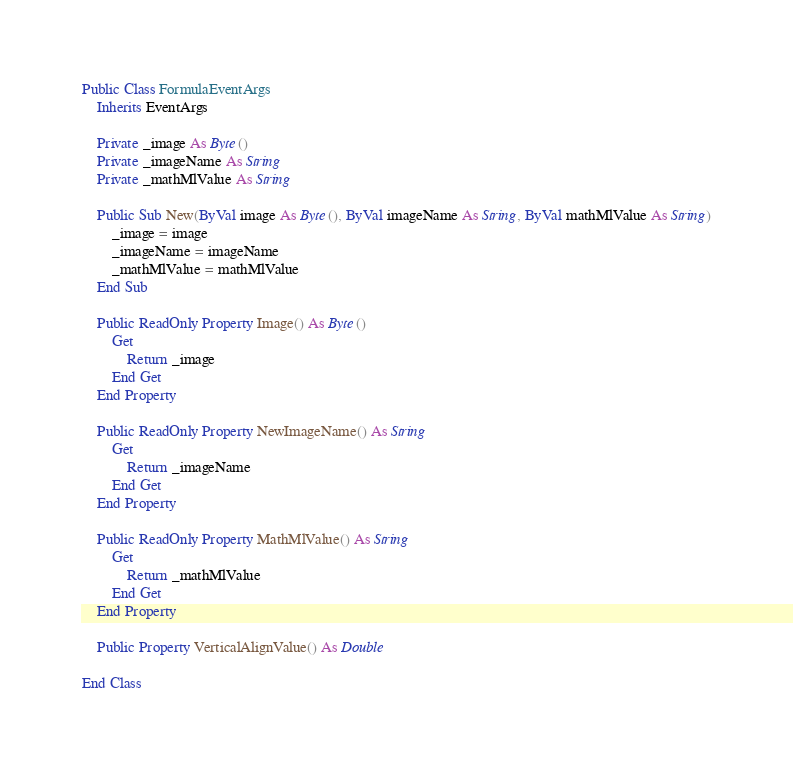Convert code to text. <code><loc_0><loc_0><loc_500><loc_500><_VisualBasic_>Public Class FormulaEventArgs
    Inherits EventArgs

    Private _image As Byte()
    Private _imageName As String
    Private _mathMlValue As String

    Public Sub New(ByVal image As Byte(), ByVal imageName As String, ByVal mathMlValue As String)
        _image = image
        _imageName = imageName
        _mathMlValue = mathMlValue
    End Sub

    Public ReadOnly Property Image() As Byte()
        Get
            Return _image
        End Get
    End Property

    Public ReadOnly Property NewImageName() As String
        Get
            Return _imageName
        End Get
    End Property

    Public ReadOnly Property MathMlValue() As String
        Get
            Return _mathMlValue
        End Get
    End Property

    Public Property VerticalAlignValue() As Double

End Class

</code> 